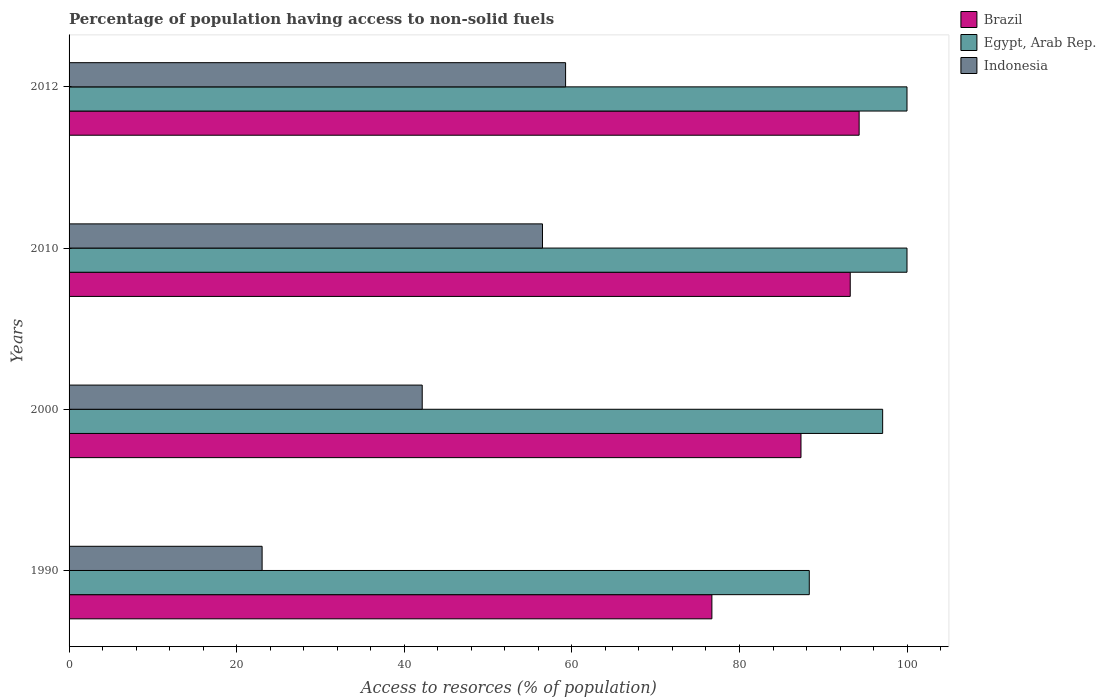How many bars are there on the 4th tick from the bottom?
Keep it short and to the point. 3. What is the percentage of population having access to non-solid fuels in Brazil in 1990?
Keep it short and to the point. 76.71. Across all years, what is the maximum percentage of population having access to non-solid fuels in Brazil?
Ensure brevity in your answer.  94.28. Across all years, what is the minimum percentage of population having access to non-solid fuels in Egypt, Arab Rep.?
Provide a succinct answer. 88.33. In which year was the percentage of population having access to non-solid fuels in Egypt, Arab Rep. maximum?
Offer a very short reply. 2010. In which year was the percentage of population having access to non-solid fuels in Indonesia minimum?
Ensure brevity in your answer.  1990. What is the total percentage of population having access to non-solid fuels in Brazil in the graph?
Your answer should be very brief. 351.54. What is the difference between the percentage of population having access to non-solid fuels in Brazil in 1990 and that in 2000?
Offer a very short reply. -10.63. What is the difference between the percentage of population having access to non-solid fuels in Brazil in 1990 and the percentage of population having access to non-solid fuels in Egypt, Arab Rep. in 2000?
Make the answer very short. -20.38. What is the average percentage of population having access to non-solid fuels in Brazil per year?
Make the answer very short. 87.89. In the year 2012, what is the difference between the percentage of population having access to non-solid fuels in Brazil and percentage of population having access to non-solid fuels in Egypt, Arab Rep.?
Ensure brevity in your answer.  -5.71. What is the ratio of the percentage of population having access to non-solid fuels in Brazil in 2010 to that in 2012?
Keep it short and to the point. 0.99. Is the difference between the percentage of population having access to non-solid fuels in Brazil in 1990 and 2012 greater than the difference between the percentage of population having access to non-solid fuels in Egypt, Arab Rep. in 1990 and 2012?
Your answer should be very brief. No. What is the difference between the highest and the second highest percentage of population having access to non-solid fuels in Indonesia?
Provide a short and direct response. 2.76. What is the difference between the highest and the lowest percentage of population having access to non-solid fuels in Brazil?
Offer a terse response. 17.57. What does the 2nd bar from the bottom in 2000 represents?
Your answer should be compact. Egypt, Arab Rep. Is it the case that in every year, the sum of the percentage of population having access to non-solid fuels in Brazil and percentage of population having access to non-solid fuels in Egypt, Arab Rep. is greater than the percentage of population having access to non-solid fuels in Indonesia?
Offer a terse response. Yes. How many bars are there?
Your answer should be very brief. 12. Are the values on the major ticks of X-axis written in scientific E-notation?
Provide a succinct answer. No. Does the graph contain grids?
Give a very brief answer. No. Where does the legend appear in the graph?
Offer a terse response. Top right. How many legend labels are there?
Offer a very short reply. 3. What is the title of the graph?
Your answer should be very brief. Percentage of population having access to non-solid fuels. What is the label or title of the X-axis?
Offer a terse response. Access to resorces (% of population). What is the Access to resorces (% of population) of Brazil in 1990?
Give a very brief answer. 76.71. What is the Access to resorces (% of population) in Egypt, Arab Rep. in 1990?
Provide a succinct answer. 88.33. What is the Access to resorces (% of population) of Indonesia in 1990?
Your answer should be compact. 23.04. What is the Access to resorces (% of population) in Brazil in 2000?
Offer a very short reply. 87.34. What is the Access to resorces (% of population) in Egypt, Arab Rep. in 2000?
Offer a very short reply. 97.09. What is the Access to resorces (% of population) in Indonesia in 2000?
Your answer should be very brief. 42.14. What is the Access to resorces (% of population) in Brazil in 2010?
Your answer should be very brief. 93.22. What is the Access to resorces (% of population) of Egypt, Arab Rep. in 2010?
Your answer should be very brief. 99.99. What is the Access to resorces (% of population) of Indonesia in 2010?
Make the answer very short. 56.49. What is the Access to resorces (% of population) in Brazil in 2012?
Your answer should be very brief. 94.28. What is the Access to resorces (% of population) in Egypt, Arab Rep. in 2012?
Offer a terse response. 99.99. What is the Access to resorces (% of population) in Indonesia in 2012?
Keep it short and to the point. 59.25. Across all years, what is the maximum Access to resorces (% of population) in Brazil?
Offer a very short reply. 94.28. Across all years, what is the maximum Access to resorces (% of population) of Egypt, Arab Rep.?
Make the answer very short. 99.99. Across all years, what is the maximum Access to resorces (% of population) in Indonesia?
Provide a short and direct response. 59.25. Across all years, what is the minimum Access to resorces (% of population) of Brazil?
Offer a very short reply. 76.71. Across all years, what is the minimum Access to resorces (% of population) in Egypt, Arab Rep.?
Your answer should be compact. 88.33. Across all years, what is the minimum Access to resorces (% of population) in Indonesia?
Ensure brevity in your answer.  23.04. What is the total Access to resorces (% of population) of Brazil in the graph?
Your response must be concise. 351.54. What is the total Access to resorces (% of population) of Egypt, Arab Rep. in the graph?
Your answer should be compact. 385.39. What is the total Access to resorces (% of population) of Indonesia in the graph?
Your answer should be compact. 180.92. What is the difference between the Access to resorces (% of population) in Brazil in 1990 and that in 2000?
Provide a short and direct response. -10.63. What is the difference between the Access to resorces (% of population) in Egypt, Arab Rep. in 1990 and that in 2000?
Your answer should be very brief. -8.76. What is the difference between the Access to resorces (% of population) of Indonesia in 1990 and that in 2000?
Offer a very short reply. -19.11. What is the difference between the Access to resorces (% of population) in Brazil in 1990 and that in 2010?
Your answer should be compact. -16.51. What is the difference between the Access to resorces (% of population) of Egypt, Arab Rep. in 1990 and that in 2010?
Make the answer very short. -11.66. What is the difference between the Access to resorces (% of population) in Indonesia in 1990 and that in 2010?
Offer a terse response. -33.46. What is the difference between the Access to resorces (% of population) of Brazil in 1990 and that in 2012?
Keep it short and to the point. -17.57. What is the difference between the Access to resorces (% of population) of Egypt, Arab Rep. in 1990 and that in 2012?
Offer a terse response. -11.66. What is the difference between the Access to resorces (% of population) in Indonesia in 1990 and that in 2012?
Offer a very short reply. -36.21. What is the difference between the Access to resorces (% of population) of Brazil in 2000 and that in 2010?
Offer a terse response. -5.88. What is the difference between the Access to resorces (% of population) of Egypt, Arab Rep. in 2000 and that in 2010?
Ensure brevity in your answer.  -2.9. What is the difference between the Access to resorces (% of population) in Indonesia in 2000 and that in 2010?
Offer a terse response. -14.35. What is the difference between the Access to resorces (% of population) in Brazil in 2000 and that in 2012?
Your answer should be compact. -6.94. What is the difference between the Access to resorces (% of population) in Egypt, Arab Rep. in 2000 and that in 2012?
Give a very brief answer. -2.9. What is the difference between the Access to resorces (% of population) of Indonesia in 2000 and that in 2012?
Provide a succinct answer. -17.11. What is the difference between the Access to resorces (% of population) of Brazil in 2010 and that in 2012?
Your answer should be very brief. -1.06. What is the difference between the Access to resorces (% of population) of Egypt, Arab Rep. in 2010 and that in 2012?
Offer a very short reply. 0. What is the difference between the Access to resorces (% of population) in Indonesia in 2010 and that in 2012?
Offer a terse response. -2.76. What is the difference between the Access to resorces (% of population) in Brazil in 1990 and the Access to resorces (% of population) in Egypt, Arab Rep. in 2000?
Give a very brief answer. -20.38. What is the difference between the Access to resorces (% of population) of Brazil in 1990 and the Access to resorces (% of population) of Indonesia in 2000?
Offer a very short reply. 34.57. What is the difference between the Access to resorces (% of population) of Egypt, Arab Rep. in 1990 and the Access to resorces (% of population) of Indonesia in 2000?
Provide a short and direct response. 46.19. What is the difference between the Access to resorces (% of population) in Brazil in 1990 and the Access to resorces (% of population) in Egypt, Arab Rep. in 2010?
Your answer should be compact. -23.28. What is the difference between the Access to resorces (% of population) in Brazil in 1990 and the Access to resorces (% of population) in Indonesia in 2010?
Offer a terse response. 20.21. What is the difference between the Access to resorces (% of population) of Egypt, Arab Rep. in 1990 and the Access to resorces (% of population) of Indonesia in 2010?
Provide a short and direct response. 31.84. What is the difference between the Access to resorces (% of population) in Brazil in 1990 and the Access to resorces (% of population) in Egypt, Arab Rep. in 2012?
Your answer should be very brief. -23.28. What is the difference between the Access to resorces (% of population) in Brazil in 1990 and the Access to resorces (% of population) in Indonesia in 2012?
Give a very brief answer. 17.46. What is the difference between the Access to resorces (% of population) of Egypt, Arab Rep. in 1990 and the Access to resorces (% of population) of Indonesia in 2012?
Provide a short and direct response. 29.08. What is the difference between the Access to resorces (% of population) of Brazil in 2000 and the Access to resorces (% of population) of Egypt, Arab Rep. in 2010?
Your answer should be very brief. -12.65. What is the difference between the Access to resorces (% of population) of Brazil in 2000 and the Access to resorces (% of population) of Indonesia in 2010?
Make the answer very short. 30.85. What is the difference between the Access to resorces (% of population) of Egypt, Arab Rep. in 2000 and the Access to resorces (% of population) of Indonesia in 2010?
Ensure brevity in your answer.  40.59. What is the difference between the Access to resorces (% of population) in Brazil in 2000 and the Access to resorces (% of population) in Egypt, Arab Rep. in 2012?
Your answer should be compact. -12.65. What is the difference between the Access to resorces (% of population) of Brazil in 2000 and the Access to resorces (% of population) of Indonesia in 2012?
Your answer should be compact. 28.09. What is the difference between the Access to resorces (% of population) of Egypt, Arab Rep. in 2000 and the Access to resorces (% of population) of Indonesia in 2012?
Your answer should be very brief. 37.83. What is the difference between the Access to resorces (% of population) in Brazil in 2010 and the Access to resorces (% of population) in Egypt, Arab Rep. in 2012?
Offer a terse response. -6.77. What is the difference between the Access to resorces (% of population) in Brazil in 2010 and the Access to resorces (% of population) in Indonesia in 2012?
Give a very brief answer. 33.97. What is the difference between the Access to resorces (% of population) of Egypt, Arab Rep. in 2010 and the Access to resorces (% of population) of Indonesia in 2012?
Keep it short and to the point. 40.74. What is the average Access to resorces (% of population) in Brazil per year?
Your answer should be compact. 87.89. What is the average Access to resorces (% of population) of Egypt, Arab Rep. per year?
Make the answer very short. 96.35. What is the average Access to resorces (% of population) of Indonesia per year?
Your response must be concise. 45.23. In the year 1990, what is the difference between the Access to resorces (% of population) in Brazil and Access to resorces (% of population) in Egypt, Arab Rep.?
Give a very brief answer. -11.62. In the year 1990, what is the difference between the Access to resorces (% of population) of Brazil and Access to resorces (% of population) of Indonesia?
Offer a terse response. 53.67. In the year 1990, what is the difference between the Access to resorces (% of population) of Egypt, Arab Rep. and Access to resorces (% of population) of Indonesia?
Your answer should be very brief. 65.29. In the year 2000, what is the difference between the Access to resorces (% of population) of Brazil and Access to resorces (% of population) of Egypt, Arab Rep.?
Provide a succinct answer. -9.75. In the year 2000, what is the difference between the Access to resorces (% of population) of Brazil and Access to resorces (% of population) of Indonesia?
Offer a terse response. 45.2. In the year 2000, what is the difference between the Access to resorces (% of population) of Egypt, Arab Rep. and Access to resorces (% of population) of Indonesia?
Make the answer very short. 54.94. In the year 2010, what is the difference between the Access to resorces (% of population) of Brazil and Access to resorces (% of population) of Egypt, Arab Rep.?
Provide a succinct answer. -6.77. In the year 2010, what is the difference between the Access to resorces (% of population) in Brazil and Access to resorces (% of population) in Indonesia?
Your answer should be compact. 36.72. In the year 2010, what is the difference between the Access to resorces (% of population) in Egypt, Arab Rep. and Access to resorces (% of population) in Indonesia?
Provide a succinct answer. 43.5. In the year 2012, what is the difference between the Access to resorces (% of population) in Brazil and Access to resorces (% of population) in Egypt, Arab Rep.?
Your answer should be very brief. -5.71. In the year 2012, what is the difference between the Access to resorces (% of population) of Brazil and Access to resorces (% of population) of Indonesia?
Offer a very short reply. 35.03. In the year 2012, what is the difference between the Access to resorces (% of population) of Egypt, Arab Rep. and Access to resorces (% of population) of Indonesia?
Offer a terse response. 40.74. What is the ratio of the Access to resorces (% of population) in Brazil in 1990 to that in 2000?
Provide a succinct answer. 0.88. What is the ratio of the Access to resorces (% of population) of Egypt, Arab Rep. in 1990 to that in 2000?
Offer a very short reply. 0.91. What is the ratio of the Access to resorces (% of population) of Indonesia in 1990 to that in 2000?
Give a very brief answer. 0.55. What is the ratio of the Access to resorces (% of population) in Brazil in 1990 to that in 2010?
Offer a very short reply. 0.82. What is the ratio of the Access to resorces (% of population) of Egypt, Arab Rep. in 1990 to that in 2010?
Offer a very short reply. 0.88. What is the ratio of the Access to resorces (% of population) in Indonesia in 1990 to that in 2010?
Offer a very short reply. 0.41. What is the ratio of the Access to resorces (% of population) in Brazil in 1990 to that in 2012?
Ensure brevity in your answer.  0.81. What is the ratio of the Access to resorces (% of population) in Egypt, Arab Rep. in 1990 to that in 2012?
Your answer should be very brief. 0.88. What is the ratio of the Access to resorces (% of population) in Indonesia in 1990 to that in 2012?
Provide a succinct answer. 0.39. What is the ratio of the Access to resorces (% of population) in Brazil in 2000 to that in 2010?
Your answer should be compact. 0.94. What is the ratio of the Access to resorces (% of population) of Egypt, Arab Rep. in 2000 to that in 2010?
Provide a short and direct response. 0.97. What is the ratio of the Access to resorces (% of population) in Indonesia in 2000 to that in 2010?
Provide a short and direct response. 0.75. What is the ratio of the Access to resorces (% of population) of Brazil in 2000 to that in 2012?
Make the answer very short. 0.93. What is the ratio of the Access to resorces (% of population) of Egypt, Arab Rep. in 2000 to that in 2012?
Offer a terse response. 0.97. What is the ratio of the Access to resorces (% of population) of Indonesia in 2000 to that in 2012?
Your answer should be very brief. 0.71. What is the ratio of the Access to resorces (% of population) of Brazil in 2010 to that in 2012?
Make the answer very short. 0.99. What is the ratio of the Access to resorces (% of population) in Indonesia in 2010 to that in 2012?
Keep it short and to the point. 0.95. What is the difference between the highest and the second highest Access to resorces (% of population) in Brazil?
Give a very brief answer. 1.06. What is the difference between the highest and the second highest Access to resorces (% of population) of Egypt, Arab Rep.?
Ensure brevity in your answer.  0. What is the difference between the highest and the second highest Access to resorces (% of population) of Indonesia?
Your answer should be compact. 2.76. What is the difference between the highest and the lowest Access to resorces (% of population) of Brazil?
Offer a terse response. 17.57. What is the difference between the highest and the lowest Access to resorces (% of population) in Egypt, Arab Rep.?
Your answer should be very brief. 11.66. What is the difference between the highest and the lowest Access to resorces (% of population) in Indonesia?
Make the answer very short. 36.21. 